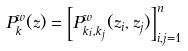<formula> <loc_0><loc_0><loc_500><loc_500>P ^ { w } _ { k } ( { z } ) = \left [ P ^ { w } _ { k _ { i } , k _ { j } } ( z _ { i } , z _ { j } ) \right ] _ { i , j = 1 } ^ { n }</formula> 